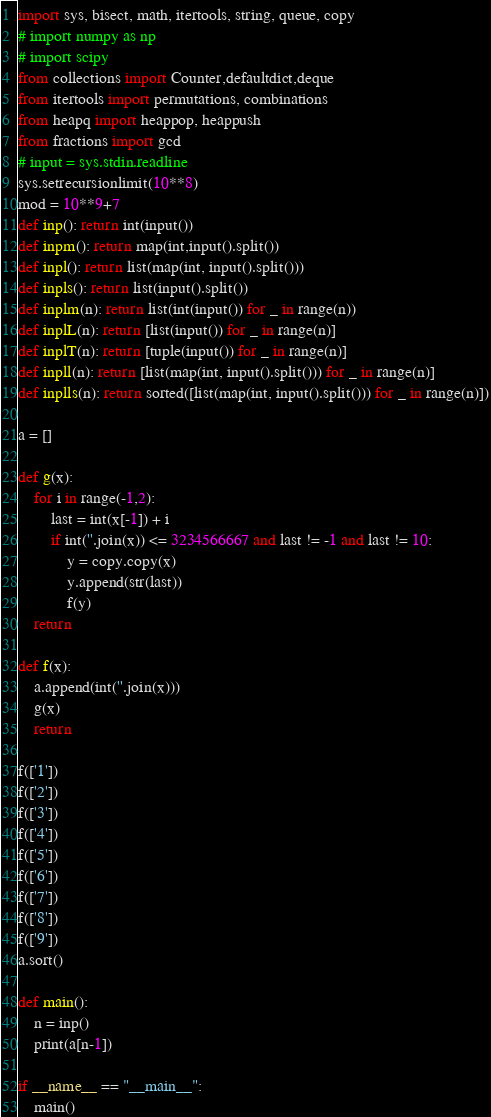Convert code to text. <code><loc_0><loc_0><loc_500><loc_500><_Python_>import sys, bisect, math, itertools, string, queue, copy
# import numpy as np
# import scipy
from collections import Counter,defaultdict,deque
from itertools import permutations, combinations
from heapq import heappop, heappush
from fractions import gcd
# input = sys.stdin.readline
sys.setrecursionlimit(10**8)
mod = 10**9+7
def inp(): return int(input())
def inpm(): return map(int,input().split())
def inpl(): return list(map(int, input().split()))
def inpls(): return list(input().split())
def inplm(n): return list(int(input()) for _ in range(n))
def inplL(n): return [list(input()) for _ in range(n)]
def inplT(n): return [tuple(input()) for _ in range(n)]
def inpll(n): return [list(map(int, input().split())) for _ in range(n)]
def inplls(n): return sorted([list(map(int, input().split())) for _ in range(n)])

a = []

def g(x):
    for i in range(-1,2):
        last = int(x[-1]) + i
        if int(''.join(x)) <= 3234566667 and last != -1 and last != 10:
            y = copy.copy(x)
            y.append(str(last))
            f(y)
    return

def f(x):
    a.append(int(''.join(x)))
    g(x)
    return

f(['1'])
f(['2'])
f(['3'])
f(['4'])
f(['5'])
f(['6'])
f(['7'])
f(['8'])
f(['9'])
a.sort()

def main():
    n = inp()
    print(a[n-1])
    
if __name__ == "__main__":
    main()</code> 